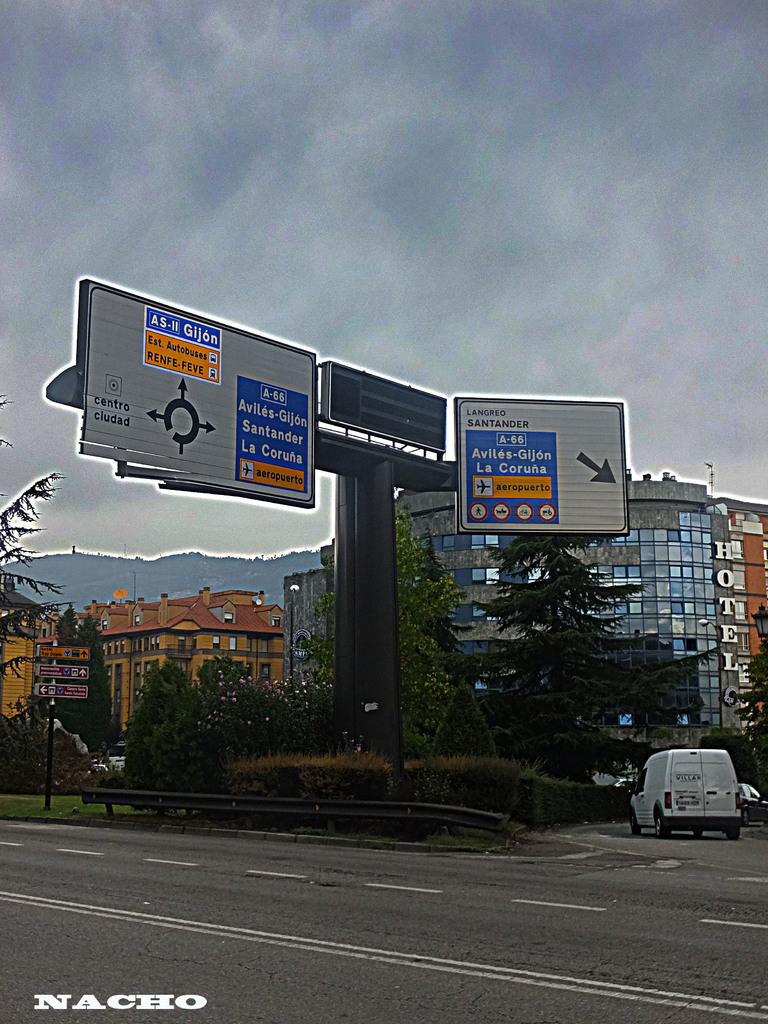What is the city name mentioned on the sign?
Offer a terse response. Unanswerable. 